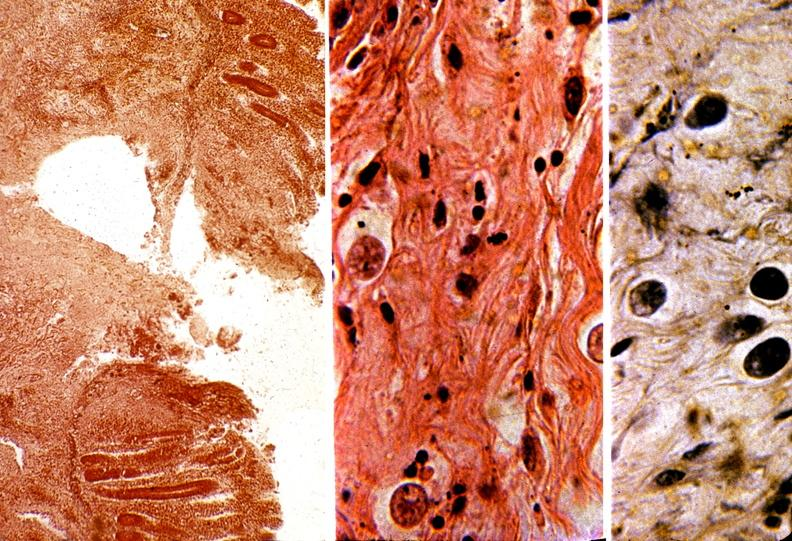what is present?
Answer the question using a single word or phrase. Gastrointestinal 